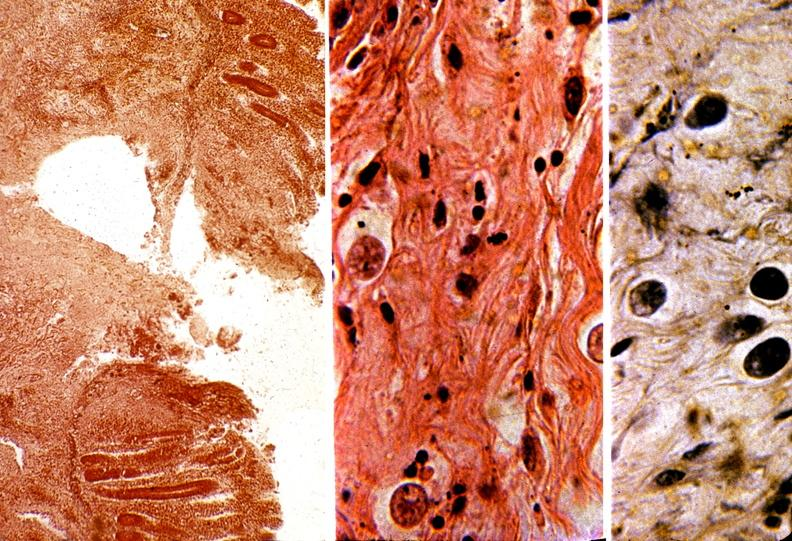what is present?
Answer the question using a single word or phrase. Gastrointestinal 